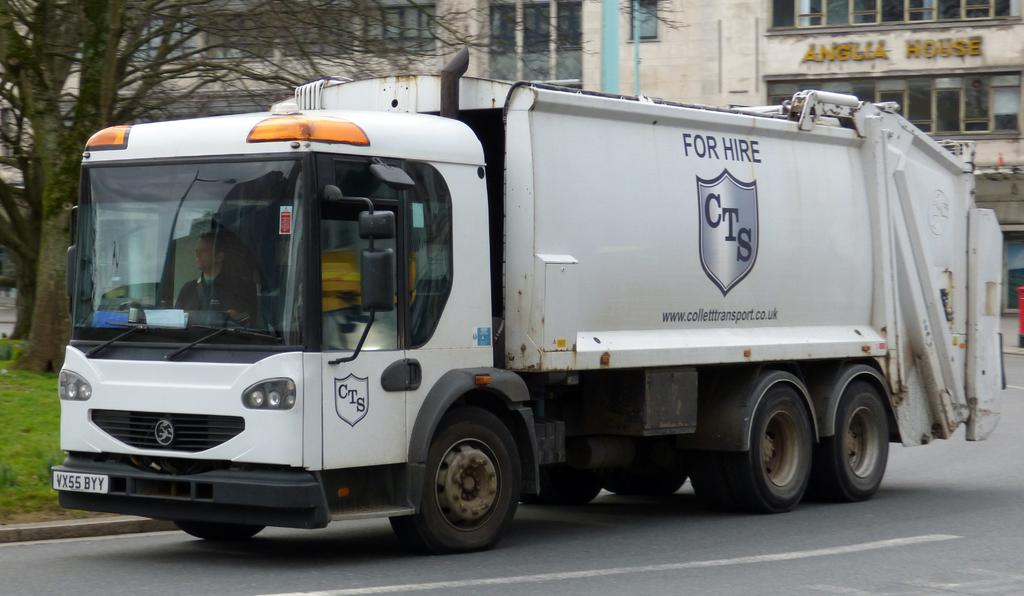What is the main subject of the image? The main subject of the image is a truck on the road. Where is the truck located in the image? The truck is in the middle of the image. What can be seen in the background of the image? There is a building and a tree in the background of the image. What type of story is being told by the fork in the image? There is no fork present in the image, so no story can be told by a fork. 